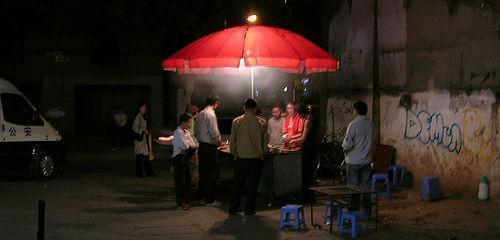What is happening under the umbrella?
Pick the correct solution from the four options below to address the question.
Options: Cleaning up, food sales, card game, discussion. Food sales. 